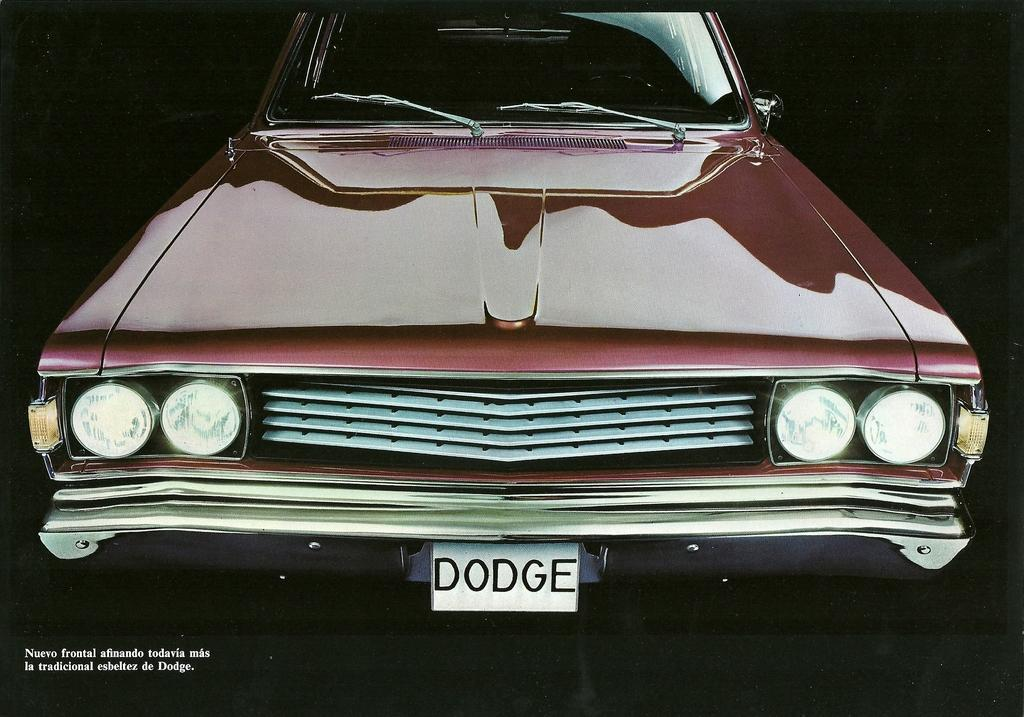What is the main subject of the image? The main subject of the image is a car. Is there any text present in the image? Yes, there is text in the bottom left corner of the image. What can be observed about the overall lighting in the image? The background of the image is dark. How many eggs are visible on the car in the image? There are no eggs present on the car in the image. What type of increase is shown in the image? The image does not depict any increase; it features a car and text in the bottom left corner. 